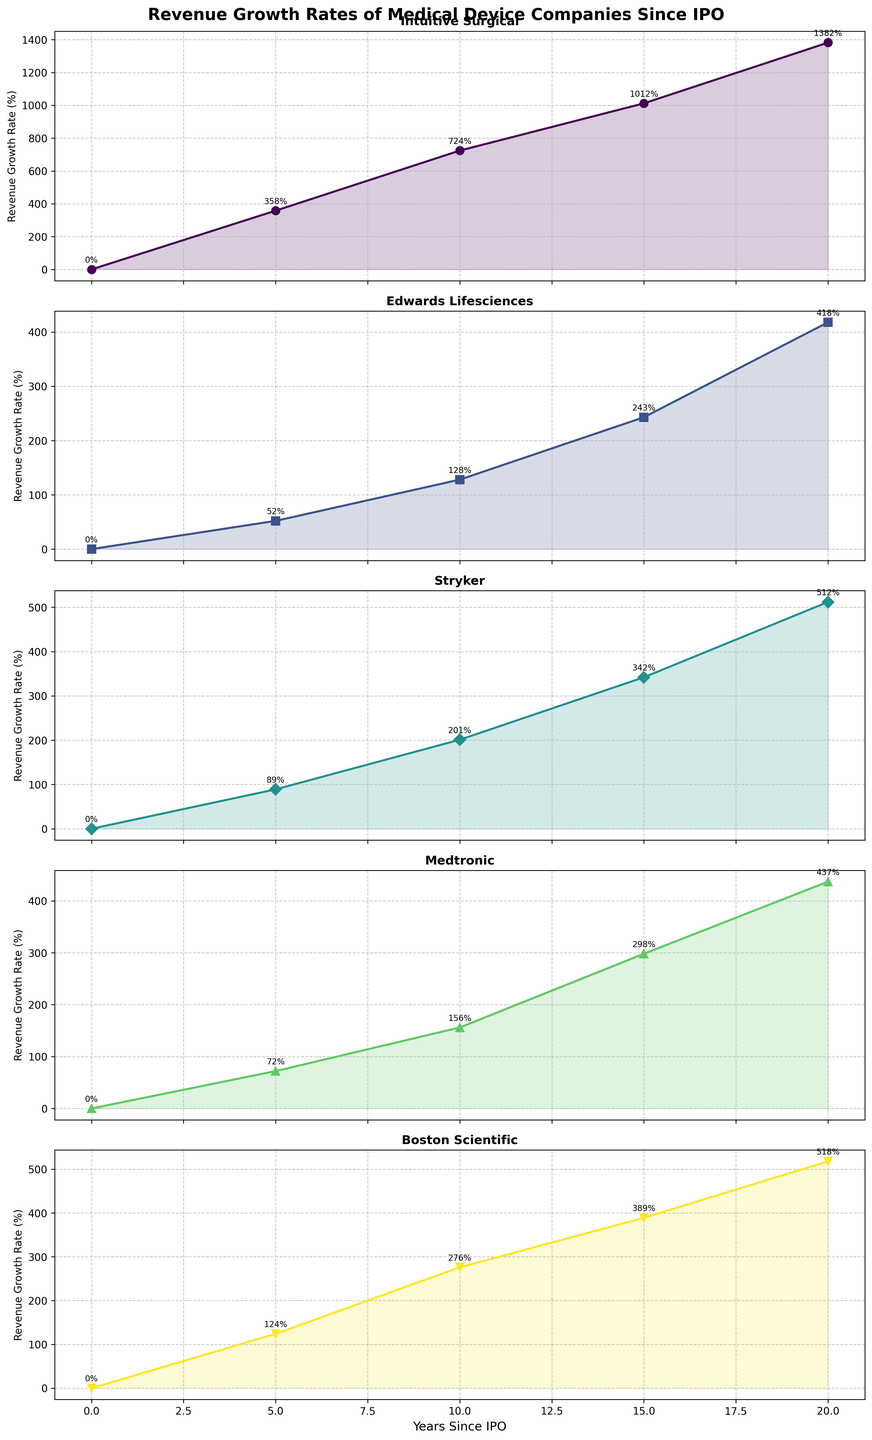Which company shows the highest revenue growth rate after 20 years since its IPO? Look at the revenue growth rates at the 20-year mark for each company. Intuitive Surgical has the highest growth rate at 1382% among all companies.
Answer: Intuitive Surgical Which company experienced the steadiest revenue growth over the 20-year period? To determine steadiness, visually inspect the plots for consistency in growth rate increases. Stryker shows relatively steady, moderate growth without large fluctuations.
Answer: Stryker How does Medtronic's revenue growth rate after 15 years compare to that of Boston Scientific? Compare Medtronic's revenue growth rate of 298% at 15 years with Boston Scientific's 389% at the same point.
Answer: Boston Scientific's rate is higher What is the average revenue growth rate of Edwards Lifesciences over the 20-year period? Sum the growth rates at the 5th, 10th, 15th, and 20th years: 52 + 128 + 243 + 418 = 841, then divide by 4 to find the average.
Answer: 210.25% By what percentage did Boston Scientific's revenue grow in the first 10 years since its IPO? Boston Scientific's 10-year revenue growth rate is stated as 276%.
Answer: 276% Which company shows the steepest increase in revenue growth in the first 5 years? Compare the 5-year revenue growth rates. Intuitive Surgical has the steepest increase from 0 to 358%.
Answer: Intuitive Surgical After 10 years since IPO, which company's revenue growth rate is closest to Stryker's growth rate at the same point? Compare Stryker's 201% growth rate with other companies. Medtronic's 156% growth rate is the closest.
Answer: Medtronic Considering the revenue growth rate trends, which two companies have similar growth patterns? Look at the shapes and slopes of the plots. Boston Scientific and Stryker show similar growth patterns, both with steady increases and significant growth over time.
Answer: Boston Scientific and Stryker 